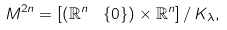<formula> <loc_0><loc_0><loc_500><loc_500>M ^ { 2 n } = [ ( \mathbb { R } ^ { n } \, \ \, \{ 0 \} ) \times \mathbb { R } ^ { n } ] \, / \, K _ { \lambda } ,</formula> 